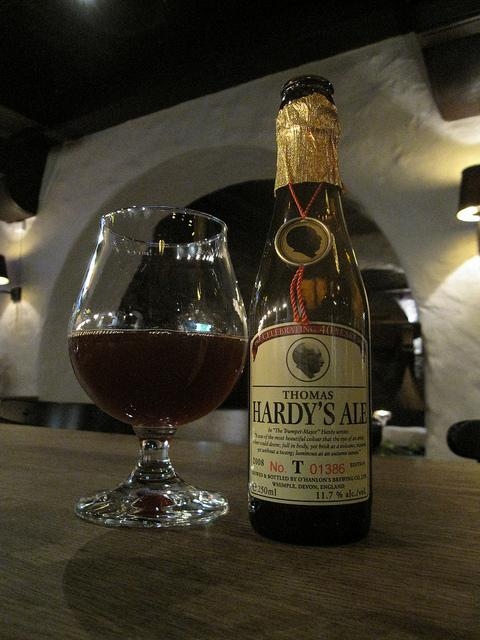What celebrity has a similar name to the name on the bottle? Please explain your reasoning. tom hardy. Tom hardy has a similar name to the brand of the bottle. 